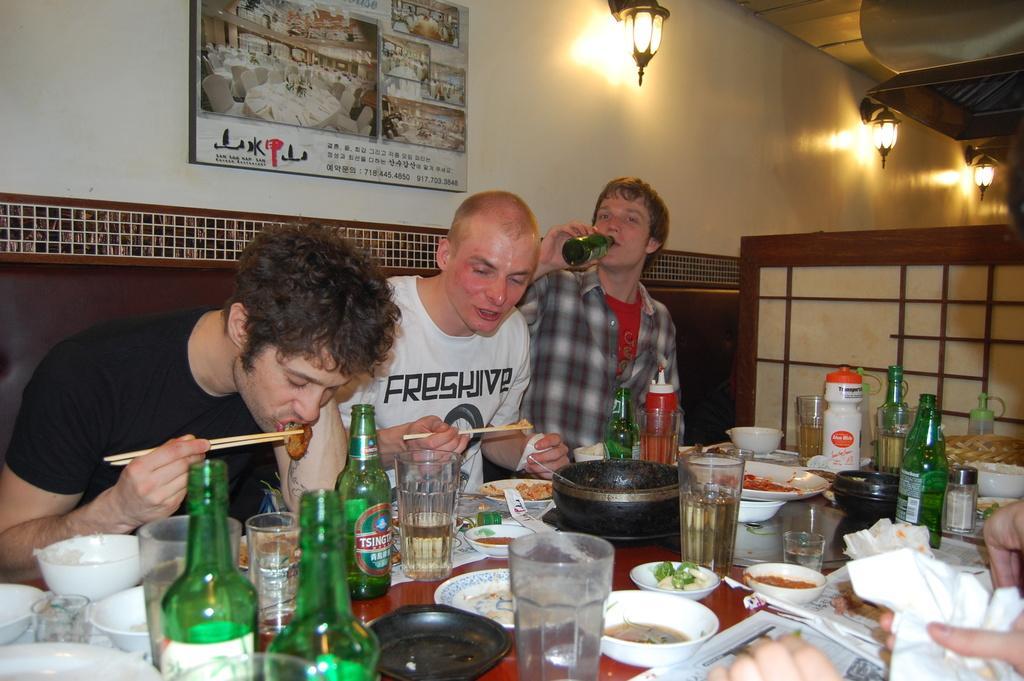Describe this image in one or two sentences. In this image the three persons are sitting on the chair and eating something food and the table has glass,bottles,bowls and plates behind the people the poster is there and three lights are there. 